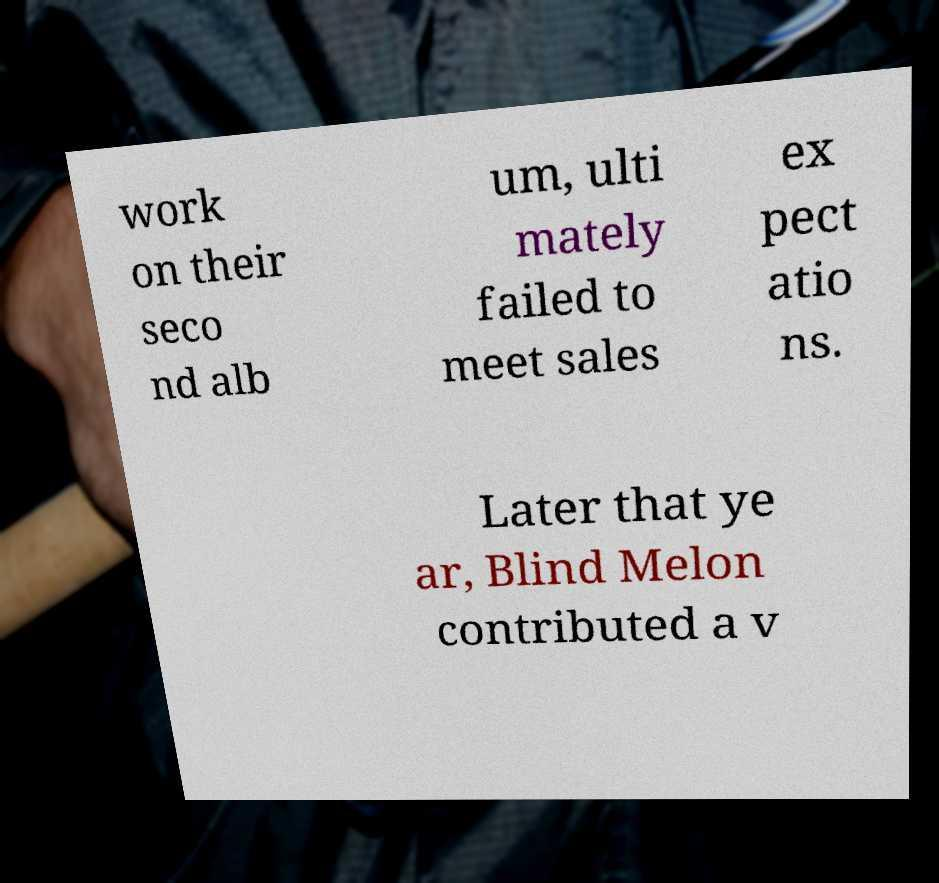Can you read and provide the text displayed in the image?This photo seems to have some interesting text. Can you extract and type it out for me? work on their seco nd alb um, ulti mately failed to meet sales ex pect atio ns. Later that ye ar, Blind Melon contributed a v 